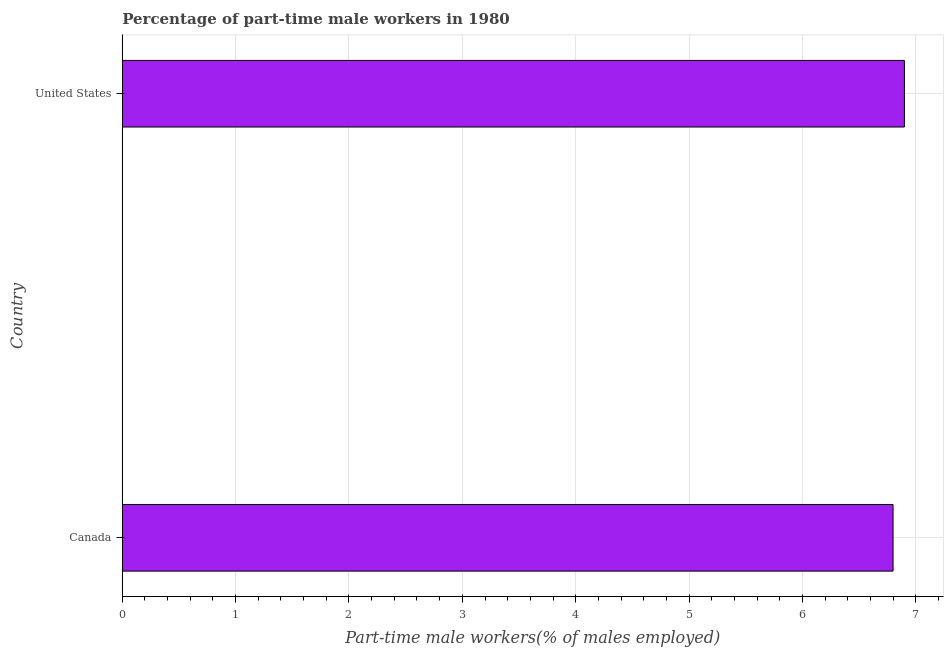Does the graph contain any zero values?
Give a very brief answer. No. What is the title of the graph?
Offer a terse response. Percentage of part-time male workers in 1980. What is the label or title of the X-axis?
Offer a very short reply. Part-time male workers(% of males employed). What is the label or title of the Y-axis?
Your answer should be very brief. Country. What is the percentage of part-time male workers in Canada?
Provide a succinct answer. 6.8. Across all countries, what is the maximum percentage of part-time male workers?
Make the answer very short. 6.9. Across all countries, what is the minimum percentage of part-time male workers?
Provide a short and direct response. 6.8. In which country was the percentage of part-time male workers maximum?
Your answer should be compact. United States. In which country was the percentage of part-time male workers minimum?
Keep it short and to the point. Canada. What is the sum of the percentage of part-time male workers?
Your answer should be very brief. 13.7. What is the difference between the percentage of part-time male workers in Canada and United States?
Offer a very short reply. -0.1. What is the average percentage of part-time male workers per country?
Offer a terse response. 6.85. What is the median percentage of part-time male workers?
Your answer should be very brief. 6.85. In how many countries, is the percentage of part-time male workers greater than 2.6 %?
Ensure brevity in your answer.  2. What is the ratio of the percentage of part-time male workers in Canada to that in United States?
Keep it short and to the point. 0.99. Is the percentage of part-time male workers in Canada less than that in United States?
Make the answer very short. Yes. How many bars are there?
Give a very brief answer. 2. Are all the bars in the graph horizontal?
Ensure brevity in your answer.  Yes. How many countries are there in the graph?
Make the answer very short. 2. Are the values on the major ticks of X-axis written in scientific E-notation?
Offer a very short reply. No. What is the Part-time male workers(% of males employed) in Canada?
Provide a short and direct response. 6.8. What is the Part-time male workers(% of males employed) of United States?
Provide a succinct answer. 6.9. What is the ratio of the Part-time male workers(% of males employed) in Canada to that in United States?
Your answer should be compact. 0.99. 